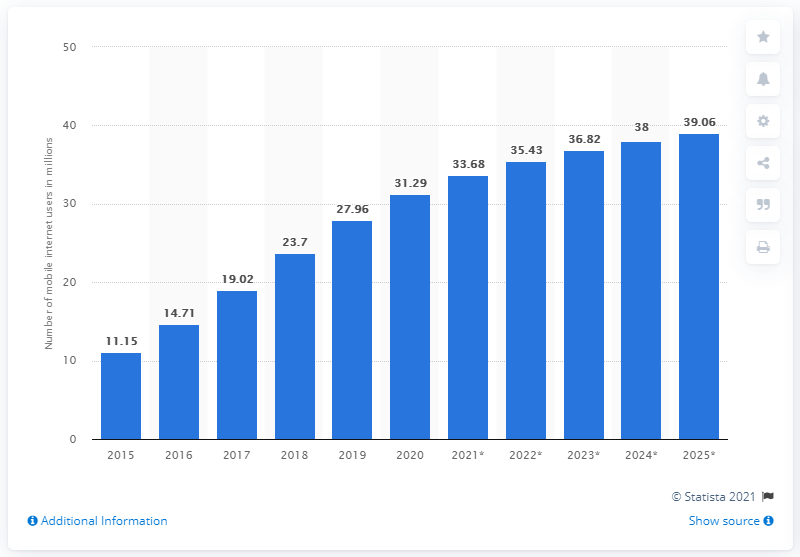Outline some significant characteristics in this image. The projected number of mobile internet users in South Africa by 2023 is expected to be approximately 39.06 million. In 2020, 31.29% of South Africans accessed the internet through a mobile device. 